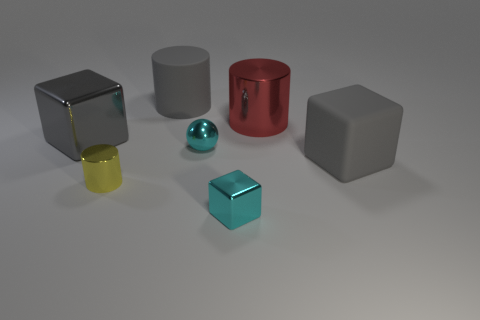Subtract all small cylinders. How many cylinders are left? 2 Subtract all purple cylinders. How many gray blocks are left? 2 Add 1 big red metallic cylinders. How many objects exist? 8 Subtract all blocks. How many objects are left? 4 Add 2 red shiny things. How many red shiny things exist? 3 Subtract 0 blue balls. How many objects are left? 7 Subtract all cyan cylinders. Subtract all purple blocks. How many cylinders are left? 3 Subtract all gray things. Subtract all large rubber cylinders. How many objects are left? 3 Add 6 big shiny cylinders. How many big shiny cylinders are left? 7 